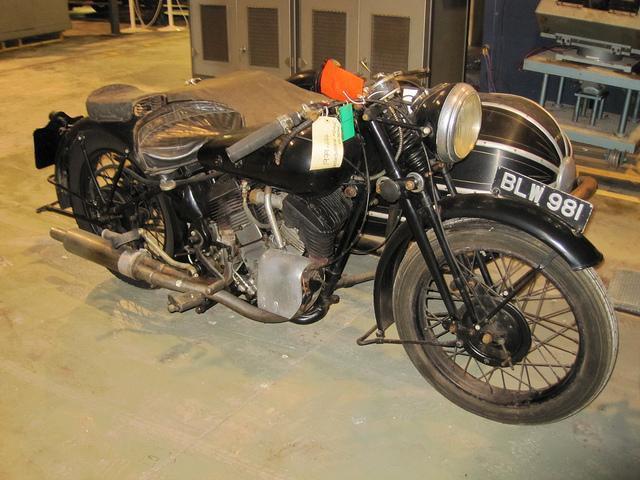How many motorcycles are there?
Give a very brief answer. 1. How many lights are on the front of this motorcycle?
Give a very brief answer. 1. 